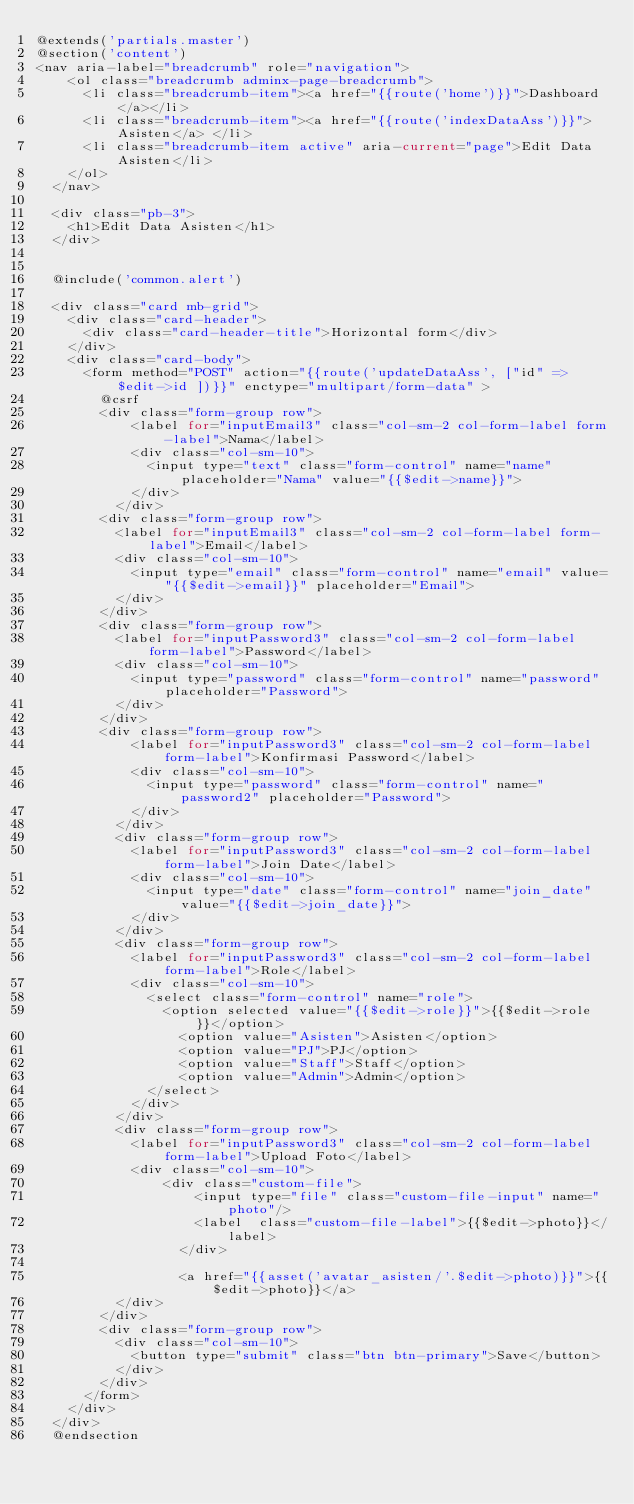<code> <loc_0><loc_0><loc_500><loc_500><_PHP_>@extends('partials.master')
@section('content')
<nav aria-label="breadcrumb" role="navigation">
    <ol class="breadcrumb adminx-page-breadcrumb">
      <li class="breadcrumb-item"><a href="{{route('home')}}">Dashboard</a></li>
      <li class="breadcrumb-item"><a href="{{route('indexDataAss')}}">Asisten</a> </li>
      <li class="breadcrumb-item active" aria-current="page">Edit Data Asisten</li>
    </ol>
  </nav>

  <div class="pb-3">
    <h1>Edit Data Asisten</h1>
  </div>


  @include('common.alert')

  <div class="card mb-grid">
    <div class="card-header">
      <div class="card-header-title">Horizontal form</div>
    </div>
    <div class="card-body">
      <form method="POST" action="{{route('updateDataAss', ["id" => $edit->id ])}}" enctype="multipart/form-data" >
        @csrf
        <div class="form-group row">
            <label for="inputEmail3" class="col-sm-2 col-form-label form-label">Nama</label>
            <div class="col-sm-10">
              <input type="text" class="form-control" name="name" placeholder="Nama" value="{{$edit->name}}">
            </div>
          </div>
        <div class="form-group row">
          <label for="inputEmail3" class="col-sm-2 col-form-label form-label">Email</label>
          <div class="col-sm-10">
            <input type="email" class="form-control" name="email" value="{{$edit->email}}" placeholder="Email">
          </div>
        </div>
        <div class="form-group row">
          <label for="inputPassword3" class="col-sm-2 col-form-label form-label">Password</label>
          <div class="col-sm-10">
            <input type="password" class="form-control" name="password" placeholder="Password">
          </div>
        </div>
        <div class="form-group row">
            <label for="inputPassword3" class="col-sm-2 col-form-label form-label">Konfirmasi Password</label>
            <div class="col-sm-10">
              <input type="password" class="form-control" name="password2" placeholder="Password">
            </div>
          </div>
          <div class="form-group row">
            <label for="inputPassword3" class="col-sm-2 col-form-label form-label">Join Date</label>
            <div class="col-sm-10">
              <input type="date" class="form-control" name="join_date" value="{{$edit->join_date}}">
            </div>
          </div>
          <div class="form-group row">
            <label for="inputPassword3" class="col-sm-2 col-form-label form-label">Role</label>
            <div class="col-sm-10">
              <select class="form-control" name="role">
                <option selected value="{{$edit->role}}">{{$edit->role}}</option>
                  <option value="Asisten">Asisten</option>
                  <option value="PJ">PJ</option>
                  <option value="Staff">Staff</option>
                  <option value="Admin">Admin</option>
              </select>
            </div>
          </div>
          <div class="form-group row">
            <label for="inputPassword3" class="col-sm-2 col-form-label form-label">Upload Foto</label>
            <div class="col-sm-10">
                <div class="custom-file">
                    <input type="file" class="custom-file-input" name="photo"/>
                    <label  class="custom-file-label">{{$edit->photo}}</label>
                  </div>

                  <a href="{{asset('avatar_asisten/'.$edit->photo)}}">{{$edit->photo}}</a>
          </div>
        </div>
        <div class="form-group row">
          <div class="col-sm-10">
            <button type="submit" class="btn btn-primary">Save</button>
          </div>
        </div>
      </form>
    </div>
  </div>
  @endsection</code> 